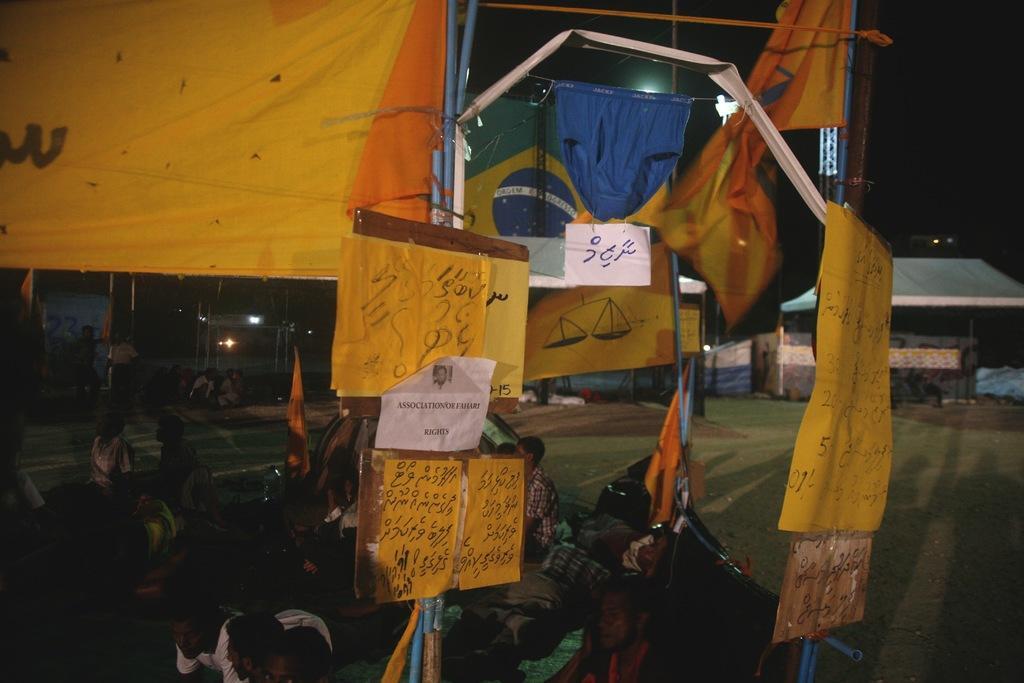Could you give a brief overview of what you see in this image? In this image in the front there are posters with some text written on it. In the center there are persons sitting and in the background there are shelters and there are lights and there is grass on the ground. 